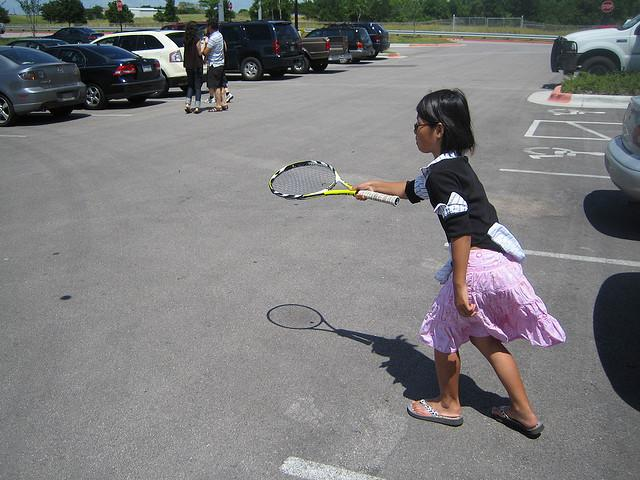Who plays the same sport? serena williams 